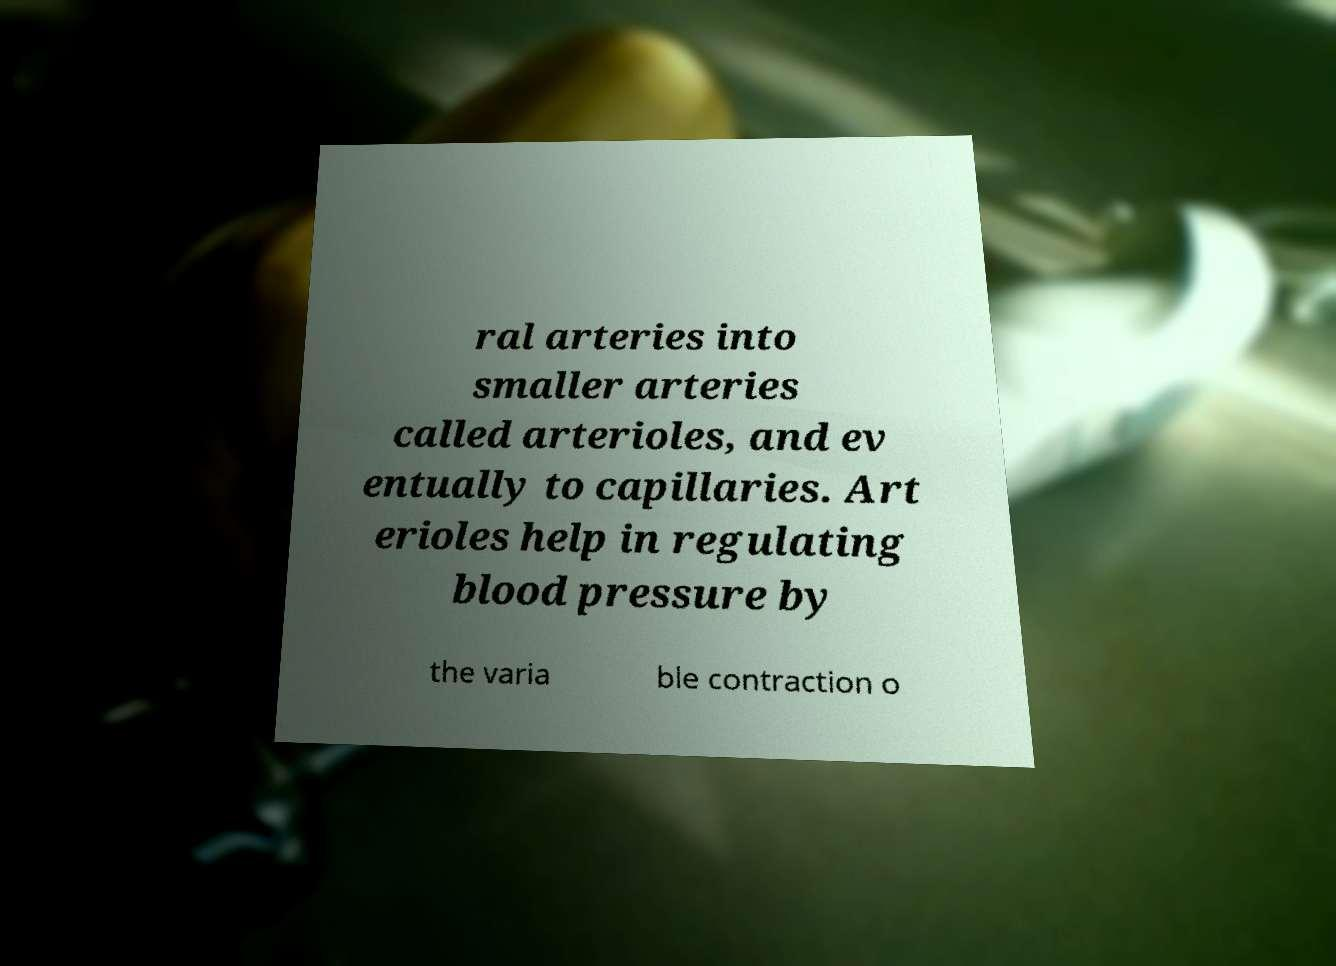Can you accurately transcribe the text from the provided image for me? ral arteries into smaller arteries called arterioles, and ev entually to capillaries. Art erioles help in regulating blood pressure by the varia ble contraction o 